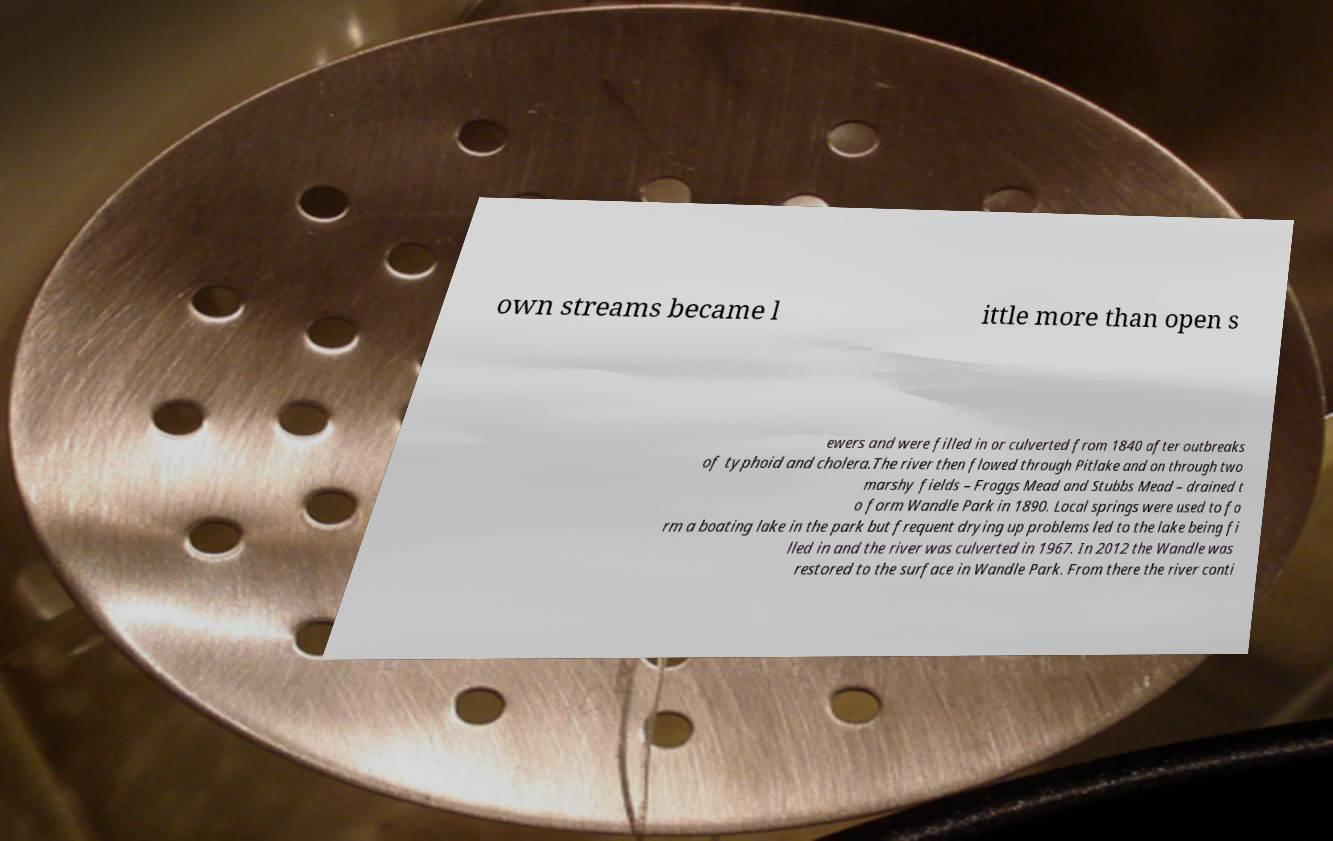What messages or text are displayed in this image? I need them in a readable, typed format. own streams became l ittle more than open s ewers and were filled in or culverted from 1840 after outbreaks of typhoid and cholera.The river then flowed through Pitlake and on through two marshy fields – Froggs Mead and Stubbs Mead – drained t o form Wandle Park in 1890. Local springs were used to fo rm a boating lake in the park but frequent drying up problems led to the lake being fi lled in and the river was culverted in 1967. In 2012 the Wandle was restored to the surface in Wandle Park. From there the river conti 